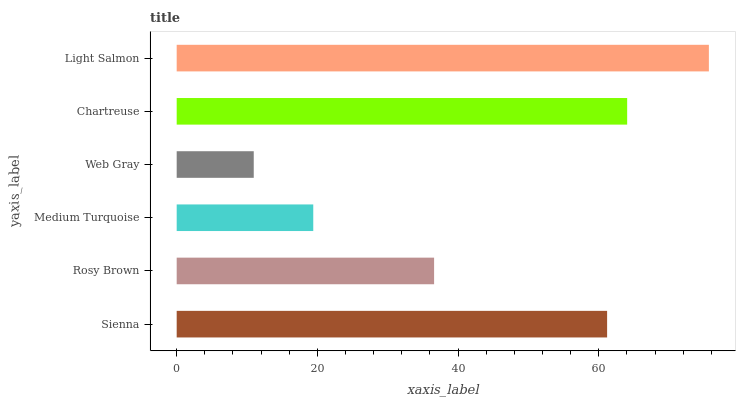Is Web Gray the minimum?
Answer yes or no. Yes. Is Light Salmon the maximum?
Answer yes or no. Yes. Is Rosy Brown the minimum?
Answer yes or no. No. Is Rosy Brown the maximum?
Answer yes or no. No. Is Sienna greater than Rosy Brown?
Answer yes or no. Yes. Is Rosy Brown less than Sienna?
Answer yes or no. Yes. Is Rosy Brown greater than Sienna?
Answer yes or no. No. Is Sienna less than Rosy Brown?
Answer yes or no. No. Is Sienna the high median?
Answer yes or no. Yes. Is Rosy Brown the low median?
Answer yes or no. Yes. Is Light Salmon the high median?
Answer yes or no. No. Is Web Gray the low median?
Answer yes or no. No. 